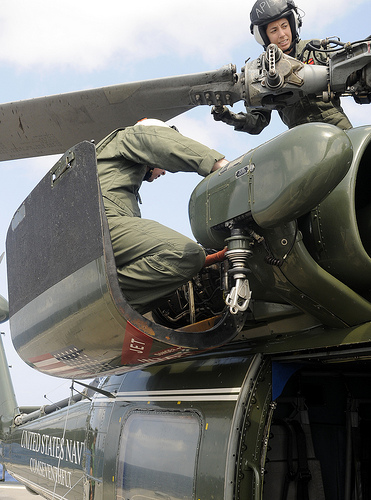<image>
Can you confirm if the propeller is on the plane? Yes. Looking at the image, I can see the propeller is positioned on top of the plane, with the plane providing support. 